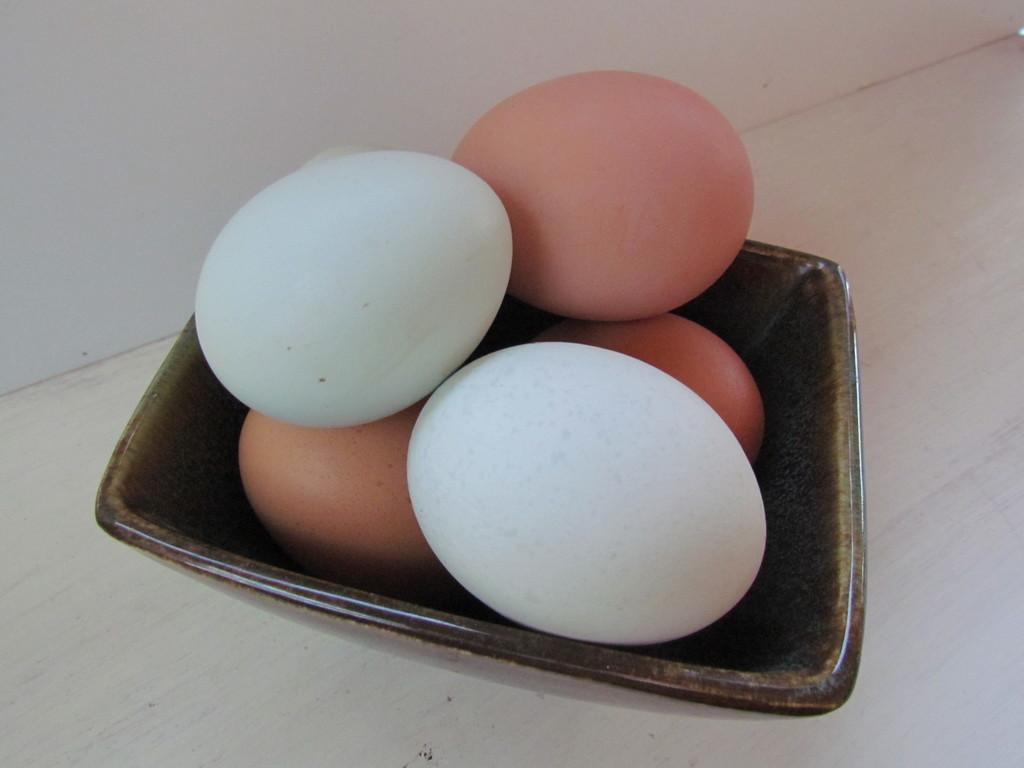What is in the bowl that is visible in the image? There are eggs in the bowl in the image. What type of surface is the bowl placed on? The bowl is on a wooden surface. What can be seen in the background of the image? There is a wall visible in the background of the image. What type of request can be seen written on the wall in the image? There is: There is no request visible on the wall in the image. 